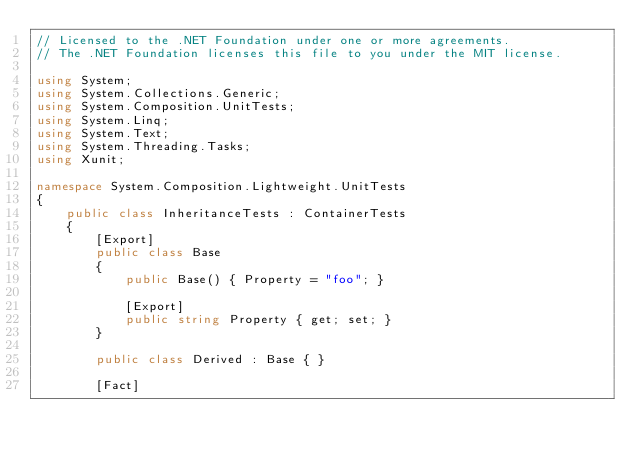Convert code to text. <code><loc_0><loc_0><loc_500><loc_500><_C#_>// Licensed to the .NET Foundation under one or more agreements.
// The .NET Foundation licenses this file to you under the MIT license.

using System;
using System.Collections.Generic;
using System.Composition.UnitTests;
using System.Linq;
using System.Text;
using System.Threading.Tasks;
using Xunit;

namespace System.Composition.Lightweight.UnitTests
{
    public class InheritanceTests : ContainerTests
    {
        [Export]
        public class Base
        {
            public Base() { Property = "foo"; }

            [Export]
            public string Property { get; set; }
        }

        public class Derived : Base { }

        [Fact]</code> 